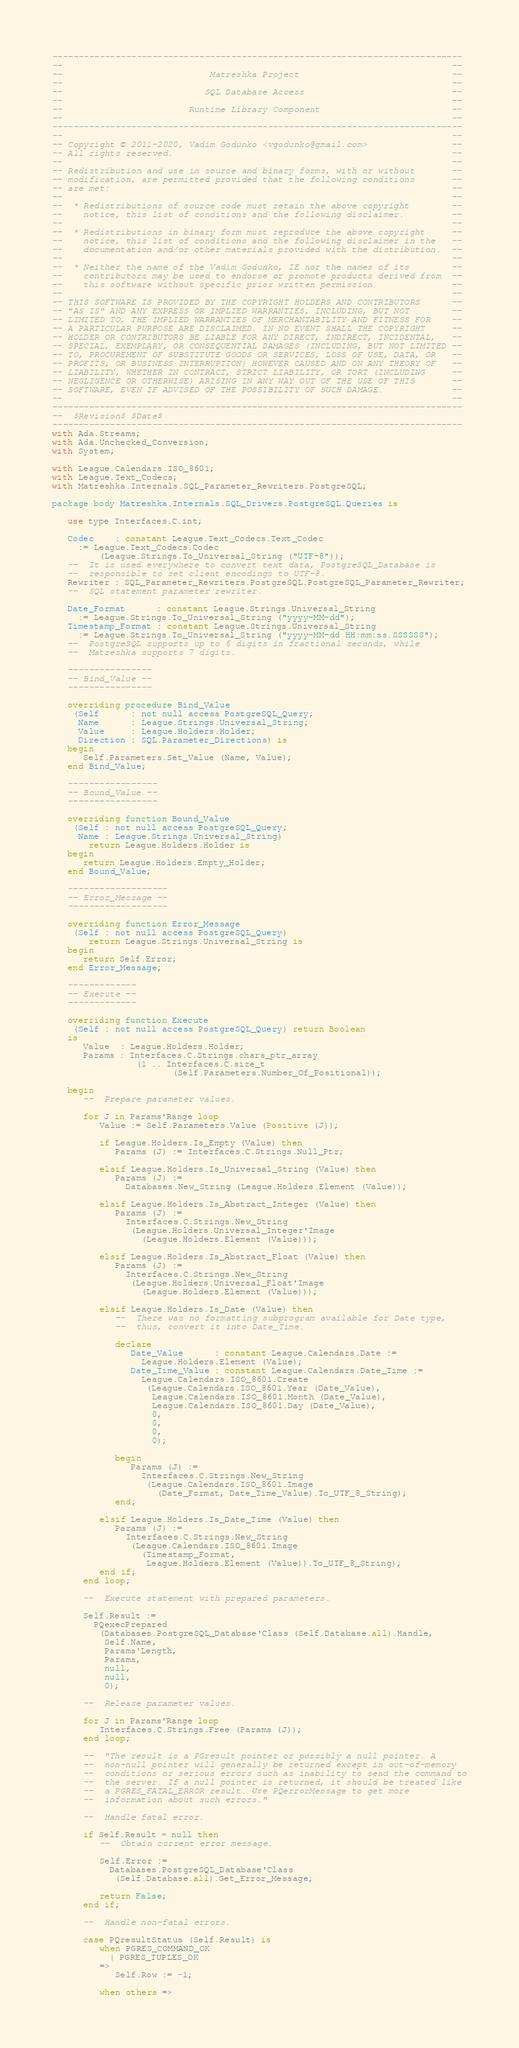Convert code to text. <code><loc_0><loc_0><loc_500><loc_500><_Ada_>------------------------------------------------------------------------------
--                                                                          --
--                            Matreshka Project                             --
--                                                                          --
--                           SQL Database Access                            --
--                                                                          --
--                        Runtime Library Component                         --
--                                                                          --
------------------------------------------------------------------------------
--                                                                          --
-- Copyright © 2011-2020, Vadim Godunko <vgodunko@gmail.com>                --
-- All rights reserved.                                                     --
--                                                                          --
-- Redistribution and use in source and binary forms, with or without       --
-- modification, are permitted provided that the following conditions       --
-- are met:                                                                 --
--                                                                          --
--  * Redistributions of source code must retain the above copyright        --
--    notice, this list of conditions and the following disclaimer.         --
--                                                                          --
--  * Redistributions in binary form must reproduce the above copyright     --
--    notice, this list of conditions and the following disclaimer in the   --
--    documentation and/or other materials provided with the distribution.  --
--                                                                          --
--  * Neither the name of the Vadim Godunko, IE nor the names of its        --
--    contributors may be used to endorse or promote products derived from  --
--    this software without specific prior written permission.              --
--                                                                          --
-- THIS SOFTWARE IS PROVIDED BY THE COPYRIGHT HOLDERS AND CONTRIBUTORS      --
-- "AS IS" AND ANY EXPRESS OR IMPLIED WARRANTIES, INCLUDING, BUT NOT        --
-- LIMITED TO, THE IMPLIED WARRANTIES OF MERCHANTABILITY AND FITNESS FOR    --
-- A PARTICULAR PURPOSE ARE DISCLAIMED. IN NO EVENT SHALL THE COPYRIGHT     --
-- HOLDER OR CONTRIBUTORS BE LIABLE FOR ANY DIRECT, INDIRECT, INCIDENTAL,   --
-- SPECIAL, EXEMPLARY, OR CONSEQUENTIAL DAMAGES (INCLUDING, BUT NOT LIMITED --
-- TO, PROCUREMENT OF SUBSTITUTE GOODS OR SERVICES; LOSS OF USE, DATA, OR   --
-- PROFITS; OR BUSINESS INTERRUPTION) HOWEVER CAUSED AND ON ANY THEORY OF   --
-- LIABILITY, WHETHER IN CONTRACT, STRICT LIABILITY, OR TORT (INCLUDING     --
-- NEGLIGENCE OR OTHERWISE) ARISING IN ANY WAY OUT OF THE USE OF THIS       --
-- SOFTWARE, EVEN IF ADVISED OF THE POSSIBILITY OF SUCH DAMAGE.             --
--                                                                          --
------------------------------------------------------------------------------
--  $Revision$ $Date$
------------------------------------------------------------------------------
with Ada.Streams;
with Ada.Unchecked_Conversion;
with System;

with League.Calendars.ISO_8601;
with League.Text_Codecs;
with Matreshka.Internals.SQL_Parameter_Rewriters.PostgreSQL;

package body Matreshka.Internals.SQL_Drivers.PostgreSQL.Queries is

   use type Interfaces.C.int;

   Codec    : constant League.Text_Codecs.Text_Codec
     := League.Text_Codecs.Codec
         (League.Strings.To_Universal_String ("UTF-8"));
   --  It is used everywhere to convert text data, PostgreSQL_Database is
   --  responsible to set client encodings to UTF-8.
   Rewriter : SQL_Parameter_Rewriters.PostgreSQL.PostgreSQL_Parameter_Rewriter;
   --  SQL statement parameter rewriter.

   Date_Format      : constant League.Strings.Universal_String
     := League.Strings.To_Universal_String ("yyyy-MM-dd");
   Timestamp_Format : constant League.Strings.Universal_String
     := League.Strings.To_Universal_String ("yyyy-MM-dd HH:mm:ss.SSSSSS");
   --  PostgreSQL supports up to 6 digits in fractional seconds, while
   --  Matreshka supports 7 digits.

   ----------------
   -- Bind_Value --
   ----------------

   overriding procedure Bind_Value
    (Self      : not null access PostgreSQL_Query;
     Name      : League.Strings.Universal_String;
     Value     : League.Holders.Holder;
     Direction : SQL.Parameter_Directions) is
   begin
      Self.Parameters.Set_Value (Name, Value);
   end Bind_Value;

   -----------------
   -- Bound_Value --
   -----------------

   overriding function Bound_Value
    (Self : not null access PostgreSQL_Query;
     Name : League.Strings.Universal_String)
       return League.Holders.Holder is
   begin
      return League.Holders.Empty_Holder;
   end Bound_Value;

   -------------------
   -- Error_Message --
   -------------------

   overriding function Error_Message
    (Self : not null access PostgreSQL_Query)
       return League.Strings.Universal_String is
   begin
      return Self.Error;
   end Error_Message;

   -------------
   -- Execute --
   -------------

   overriding function Execute
    (Self : not null access PostgreSQL_Query) return Boolean
   is
      Value  : League.Holders.Holder;
      Params : Interfaces.C.Strings.chars_ptr_array
                (1 .. Interfaces.C.size_t
                       (Self.Parameters.Number_Of_Positional));

   begin
      --  Prepare parameter values.

      for J in Params'Range loop
         Value := Self.Parameters.Value (Positive (J));

         if League.Holders.Is_Empty (Value) then
            Params (J) := Interfaces.C.Strings.Null_Ptr;

         elsif League.Holders.Is_Universal_String (Value) then
            Params (J) :=
              Databases.New_String (League.Holders.Element (Value));

         elsif League.Holders.Is_Abstract_Integer (Value) then
            Params (J) :=
              Interfaces.C.Strings.New_String
               (League.Holders.Universal_Integer'Image
                 (League.Holders.Element (Value)));

         elsif League.Holders.Is_Abstract_Float (Value) then
            Params (J) :=
              Interfaces.C.Strings.New_String
               (League.Holders.Universal_Float'Image
                 (League.Holders.Element (Value)));

         elsif League.Holders.Is_Date (Value) then
            --  There was no formatting subprogram available for Date type,
            --  thus, convert it into Date_Time.

            declare
               Date_Value      : constant League.Calendars.Date :=
                 League.Holders.Element (Value);
               Date_Time_Value : constant League.Calendars.Date_Time :=
                 League.Calendars.ISO_8601.Create
                  (League.Calendars.ISO_8601.Year (Date_Value),
                   League.Calendars.ISO_8601.Month (Date_Value),
                   League.Calendars.ISO_8601.Day (Date_Value),
                   0,
                   0,
                   0,
                   0);

            begin
               Params (J) :=
                 Interfaces.C.Strings.New_String
                  (League.Calendars.ISO_8601.Image
                    (Date_Format, Date_Time_Value).To_UTF_8_String);
            end;

         elsif League.Holders.Is_Date_Time (Value) then
            Params (J) :=
              Interfaces.C.Strings.New_String
               (League.Calendars.ISO_8601.Image
                 (Timestamp_Format,
                  League.Holders.Element (Value)).To_UTF_8_String);
         end if;
      end loop;

      --  Execute statement with prepared parameters.

      Self.Result :=
        PQexecPrepared
         (Databases.PostgreSQL_Database'Class (Self.Database.all).Handle,
          Self.Name,
          Params'Length,
          Params,
          null,
          null,
          0);

      --  Release parameter values.

      for J in Params'Range loop
         Interfaces.C.Strings.Free (Params (J));
      end loop;

      --  "The result is a PGresult pointer or possibly a null pointer. A
      --  non-null pointer will generally be returned except in out-of-memory
      --  conditions or serious errors such as inability to send the command to
      --  the server. If a null pointer is returned, it should be treated like
      --  a PGRES_FATAL_ERROR result. Use PQerrorMessage to get more
      --  information about such errors."

      --  Handle fatal error.

      if Self.Result = null then
         --  Obtain current error message.

         Self.Error :=
           Databases.PostgreSQL_Database'Class
            (Self.Database.all).Get_Error_Message;

         return False;
      end if;

      --  Handle non-fatal errors.

      case PQresultStatus (Self.Result) is
         when PGRES_COMMAND_OK
           | PGRES_TUPLES_OK
         =>
            Self.Row := -1;

         when others =></code> 